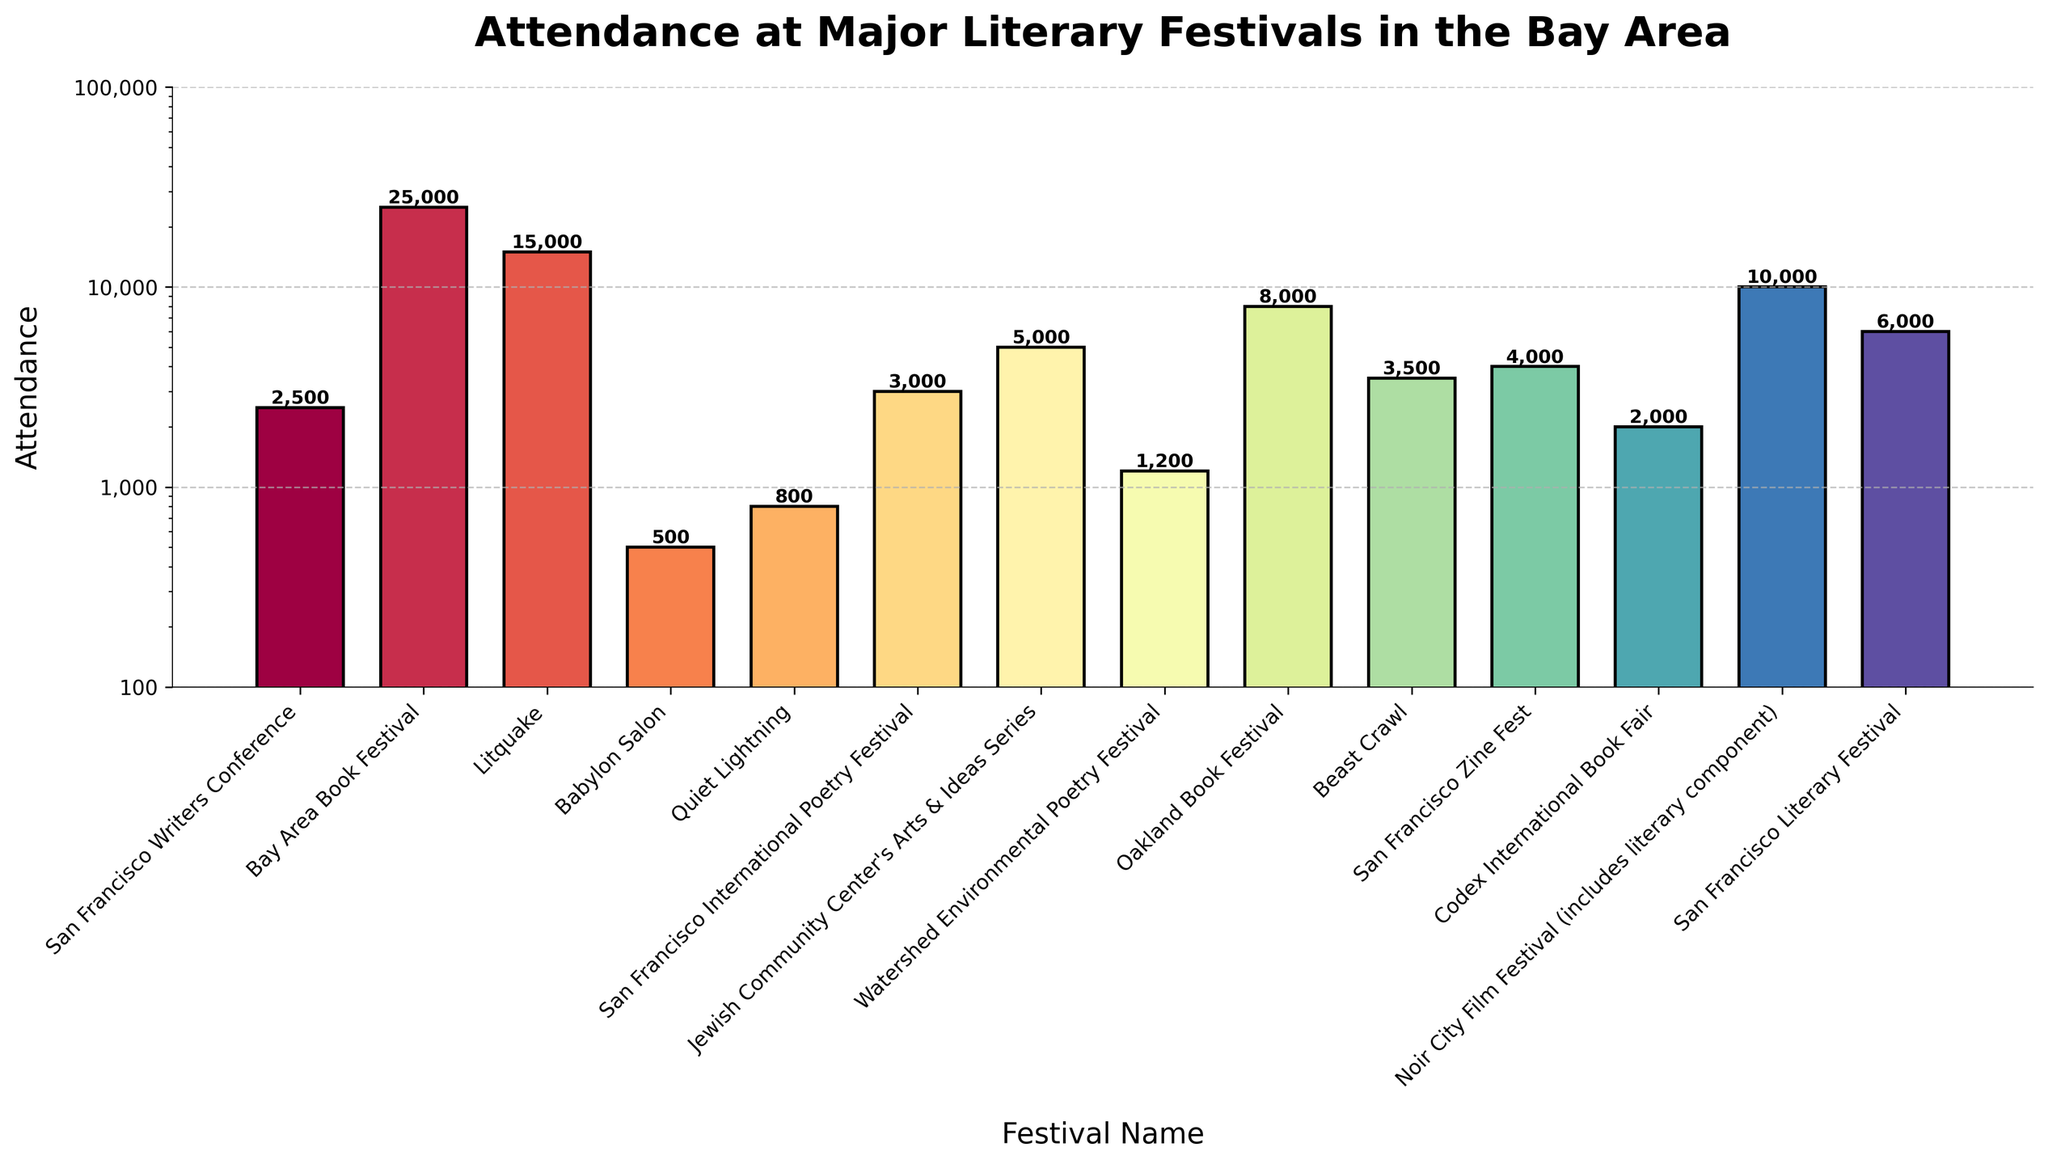Which festival has the highest attendance? To find the festival with the highest attendance, we look for the tallest bar. The Bay Area Book Festival has the highest attendance with 25,000 attendees.
Answer: Bay Area Book Festival Which festival has the lowest attendance? To identify the festival with the lowest attendance, we look for the shortest bar. Babylon Salon has the lowest attendance with 500 attendees.
Answer: Babylon Salon What is the total attendance for the San Francisco Writers Conference and the Bay Area Book Festival combined? To find the combined attendance, we add the attendance numbers for both festivals: San Francisco Writers Conference (2,500) + Bay Area Book Festival (25,000) = 27,500 attendees.
Answer: 27,500 Which festival has more attendees: Litquake or Noir City Film Festival? We compare the heights of the bars for Litquake and Noir City Film Festival. Litquake has 15,000 attendees and Noir City Film Festival has 10,000 attendees, so Litquake has more attendees.
Answer: Litquake Which festival has the median attendance? To find the median attendance, we list all attendance figures and find the middle value. The sorted attendances are (500, 800, 1,200, 2,000, 2,500, 3,000, 3,500, 4,000, 5,000, 6,000, 8,000, 10,000, 15,000, 25,000). The median value, being the 7th value in this sequence, is 3,500, corresponding to Beast Crawl.
Answer: Beast Crawl What is the difference in attendance between the San Francisco International Poetry Festival and the San Francisco Writers Conference? To find the difference in attendance, subtract the attendance of the San Francisco Writers Conference (2,500) from the San Francisco International Poetry Festival (3,000): 3,000 - 2,500 = 500 attendees.
Answer: 500 Which festival has a higher attendance: the San Francisco Literary Festival or the Oakland Book Festival? We compare the heights of the bars for the San Francisco Literary Festival and the Oakland Book Festival. The San Francisco Literary Festival has an attendance of 6,000, and the Oakland Book Festival has an attendance of 8,000, so the Oakland Book Festival has a higher attendance.
Answer: Oakland Book Festival What is the average attendance of all the festivals? To find the average attendance, sum all attendance numbers and divide by the number of festivals. The total attendance is (500 + 800 + 1,200 + 2,000 + 2,500 + 3,000 + 3,500 + 4,000 + 5,000 + 6,000 + 8,000 + 10,000 + 15,000 + 25,000) = 86,500, and there are 14 festivals. So, 86,500 / 14 = 6,179 attendees (rounded).
Answer: 6,179 How many festivals have an attendance greater than 10,000? To find how many festivals have attendance greater than 10,000, count the bars with attendance above this value. These festivals are Bay Area Book Festival (25,000) and Litquake (15,000). So, there are 2 festivals.
Answer: 2 